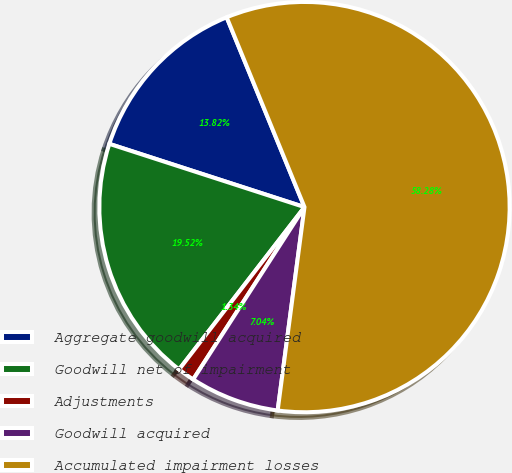Convert chart to OTSL. <chart><loc_0><loc_0><loc_500><loc_500><pie_chart><fcel>Aggregate goodwill acquired<fcel>Goodwill net of impairment<fcel>Adjustments<fcel>Goodwill acquired<fcel>Accumulated impairment losses<nl><fcel>13.82%<fcel>19.52%<fcel>1.34%<fcel>7.04%<fcel>58.28%<nl></chart> 